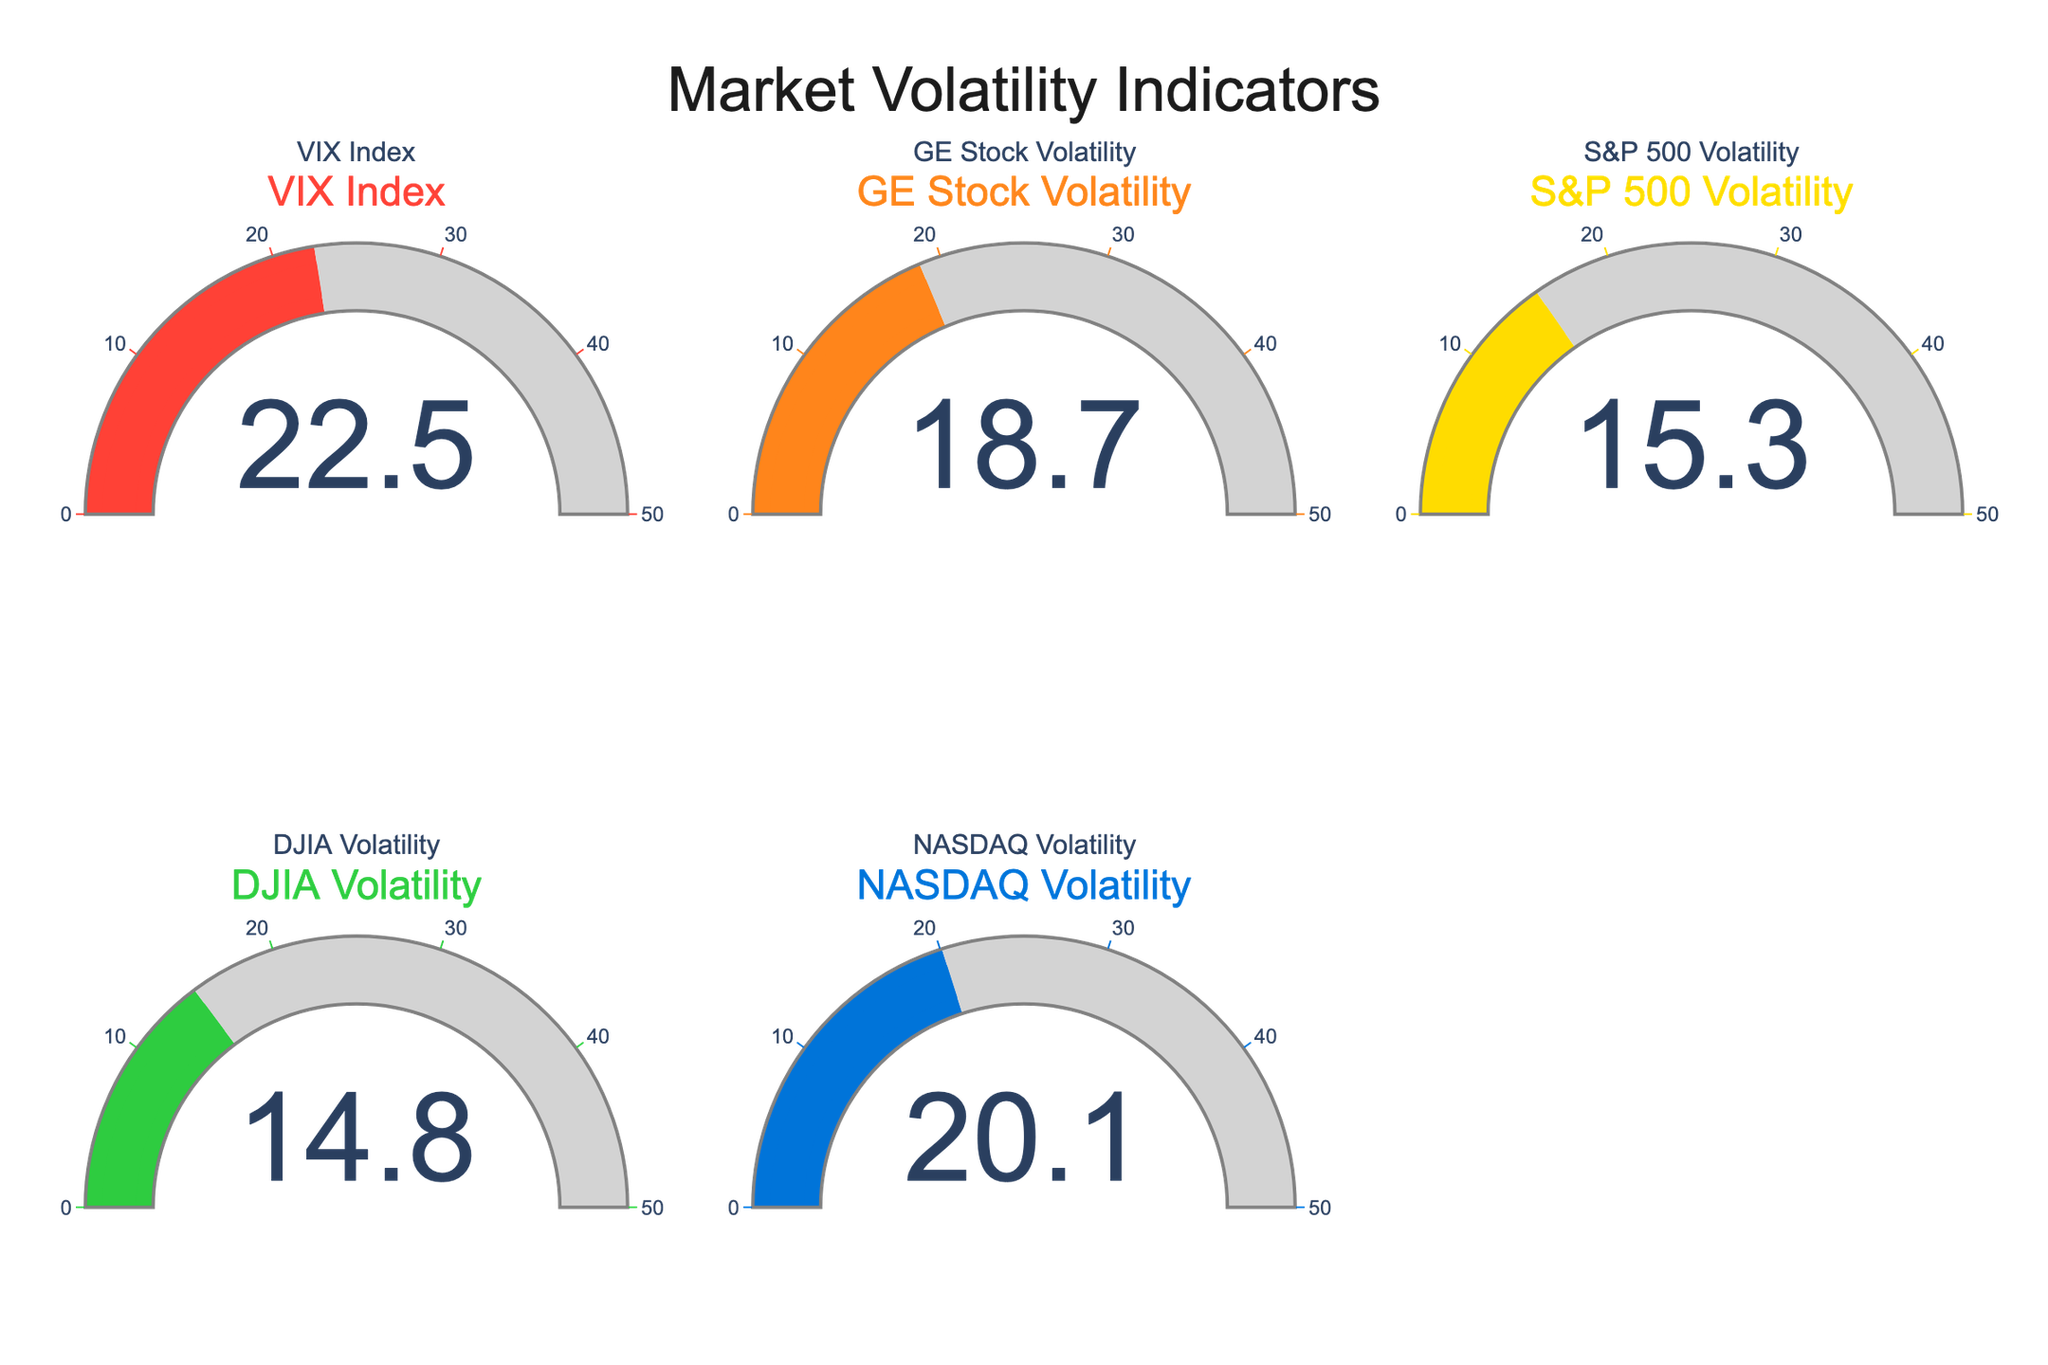What's the current value of the VIX Index? To find the current value of the VIX Index, identify the gauge labeled "VIX Index" and read the displayed number inside the gauge. The value shown is 22.5.
Answer: 22.5 Which volatility measure has the lowest value? To determine the lowest volatility value, review each gauge and compare the values. The values are: VIX Index (22.5), GE Stock Volatility (18.7), S&P 500 Volatility (15.3), DJIA Volatility (14.8), and NASDAQ Volatility (20.1). Among these, the DJIA Volatility is the lowest at 14.8.
Answer: DJIA Volatility (14.8) What is the sum of the volatility values for NASDAQ and GE Stock? To find the sum of the NASDAQ and GE Stock Volatility values, add the numbers shown in the respective gauges. NASDAQ Volatility is 20.1, and GE Stock Volatility is 18.7. The sum is 20.1 + 18.7 = 38.8.
Answer: 38.8 Which volatility measure is closest to the VIX Index? To determine which measure is closest to the VIX Index value of 22.5, compare the differences between 22.5 and the values of the other indices: (22.5 - 18.7 = 3.8), (22.5 - 15.3 = 7.2), (22.5 - 14.8 = 7.7), and (22.5 - 20.1 = 2.4). The closest value is NASDAQ Volatility at 20.1 with a difference of 2.4.
Answer: NASDAQ Volatility What is the average volatility value across all the measures? To find the average volatility value, sum all displayed values and divide by the number of measures. The values are: 22.5 (VIX Index), 18.7 (GE Stock Volatility), 15.3 (S&P 500 Volatility), 14.8 (DJIA Volatility), and 20.1 (NASDAQ Volatility). The total sum is 91.4, and there are 5 measures. The average is 91.4 / 5 = 18.28.
Answer: 18.28 